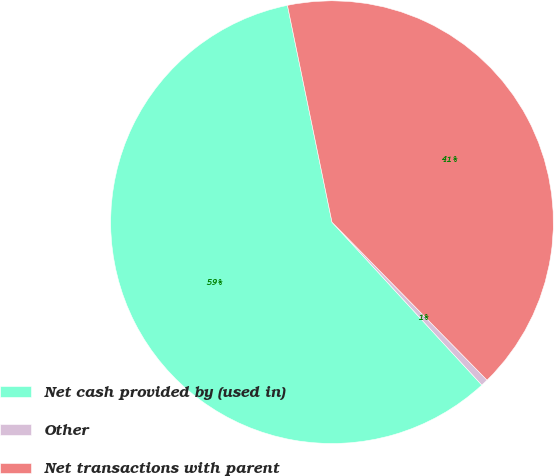Convert chart to OTSL. <chart><loc_0><loc_0><loc_500><loc_500><pie_chart><fcel>Net cash provided by (used in)<fcel>Other<fcel>Net transactions with parent<nl><fcel>58.6%<fcel>0.52%<fcel>40.87%<nl></chart> 